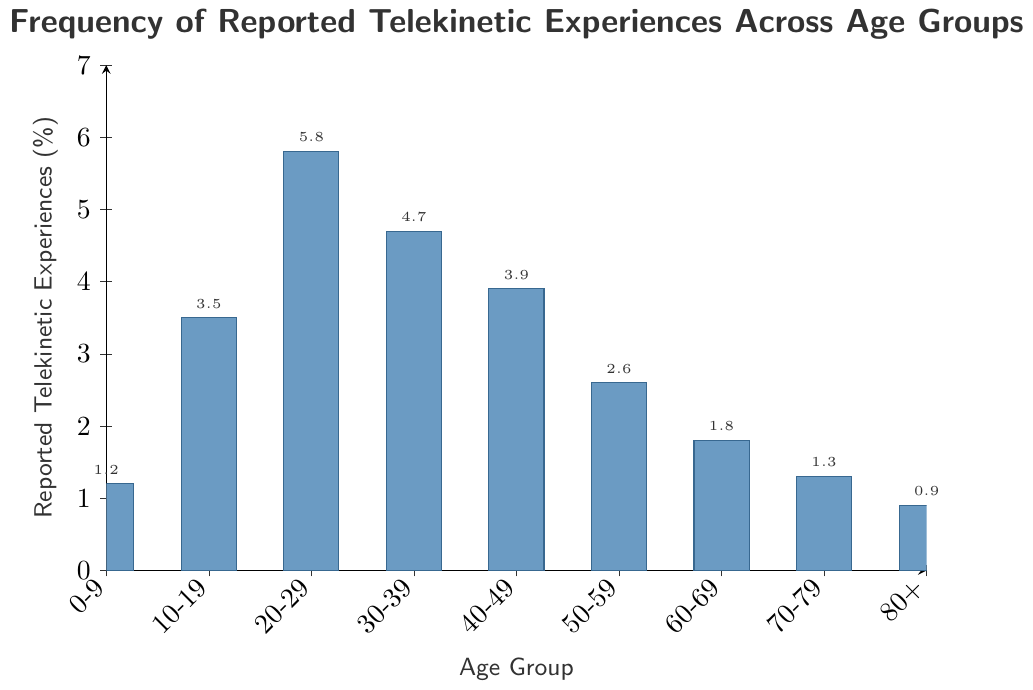Which age group reports the highest percentage of telekinetic experiences? To find the age group with the highest percentage, look for the tallest bar in the chart. The tallest bar corresponds to the age group 20-29, with a height of 5.8%.
Answer: 20-29 Which age group reports the lowest percentage of telekinetic experiences? To determine the age group with the lowest percentage, identify the shortest bar in the chart. The shortest bar corresponds to the age group 80+, with a height of 0.9%.
Answer: 80+ What is the difference in the percentage of reported telekinetic experiences between the age group 20-29 and 50-59? Subtract the percentage of the 50-59 age group (2.6%) from that of the 20-29 age group (5.8%). The difference is 5.8% - 2.6% = 3.2%.
Answer: 3.2% What is the average percentage of reported telekinetic experiences for age groups 0-9, 10-19, and 20-29? Calculate the average by summing the percentages of the three age groups (1.2% + 3.5% + 5.8%) and then dividing by 3. The sum is 10.5%, so the average is 10.5%/3 = 3.5%.
Answer: 3.5% How does the frequency of reported telekinetic experiences in the age group 30-39 compare to the age group 40-49? Compare the heights of the bars for the age groups 30-39 (4.7%) and 40-49 (3.9%). The 30-39 age group has a higher percentage.
Answer: Higher What is the total percentage of reported telekinetic experiences for all age groups combined? Sum the percentages for all age groups: 1.2% + 3.5% + 5.8% + 4.7% + 3.9% + 2.6% + 1.8% + 1.3% + 0.9% = 25.7%.
Answer: 25.7% Which age groups report more than 4% of telekinetic experiences? Identify the bars with heights greater than 4%. These correspond to the age groups 20-29 (5.8%) and 30-39 (4.7%).
Answer: 20-29, 30-39 How many age groups report less than 2% of telekinetic experiences? Count the bars with heights less than 2%. These correspond to the age groups 0-9 (1.2%), 60-69 (1.8%), 70-79 (1.3%), and 80+ (0.9%). There are four such age groups.
Answer: 4 What is the median percentage of reported telekinetic experiences? To find the median, list the percentages in ascending order: 0.9%, 1.2%, 1.3%, 1.8%, 2.6%, 3.5%, 3.9%, 4.7%, and 5.8%. The median is the fifth value in the ordered list, which is 2.6%.
Answer: 2.6% In which age group does the frequency of reported telekinetic experiences decrease most significantly from the previous age group? Look for the largest negative difference between consecutive age groups. The most significant decrease is from the age group 20-29 (5.8%) to the age group 30-39 (4.7%), with a difference of 1.1%.
Answer: 20-29 to 30-39 